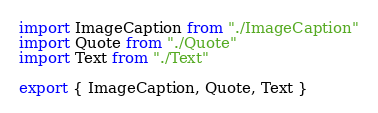<code> <loc_0><loc_0><loc_500><loc_500><_JavaScript_>import ImageCaption from "./ImageCaption"
import Quote from "./Quote"
import Text from "./Text"

export { ImageCaption, Quote, Text }
</code> 